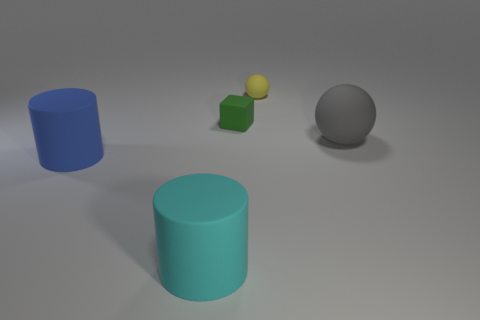Add 3 large yellow matte things. How many objects exist? 8 Subtract all cylinders. How many objects are left? 3 Add 5 cyan objects. How many cyan objects exist? 6 Subtract all cyan cylinders. How many cylinders are left? 1 Subtract 0 red cylinders. How many objects are left? 5 Subtract 1 blocks. How many blocks are left? 0 Subtract all cyan cubes. Subtract all blue balls. How many cubes are left? 1 Subtract all yellow balls. How many brown cubes are left? 0 Subtract all tiny yellow matte spheres. Subtract all big blue metallic balls. How many objects are left? 4 Add 4 green rubber blocks. How many green rubber blocks are left? 5 